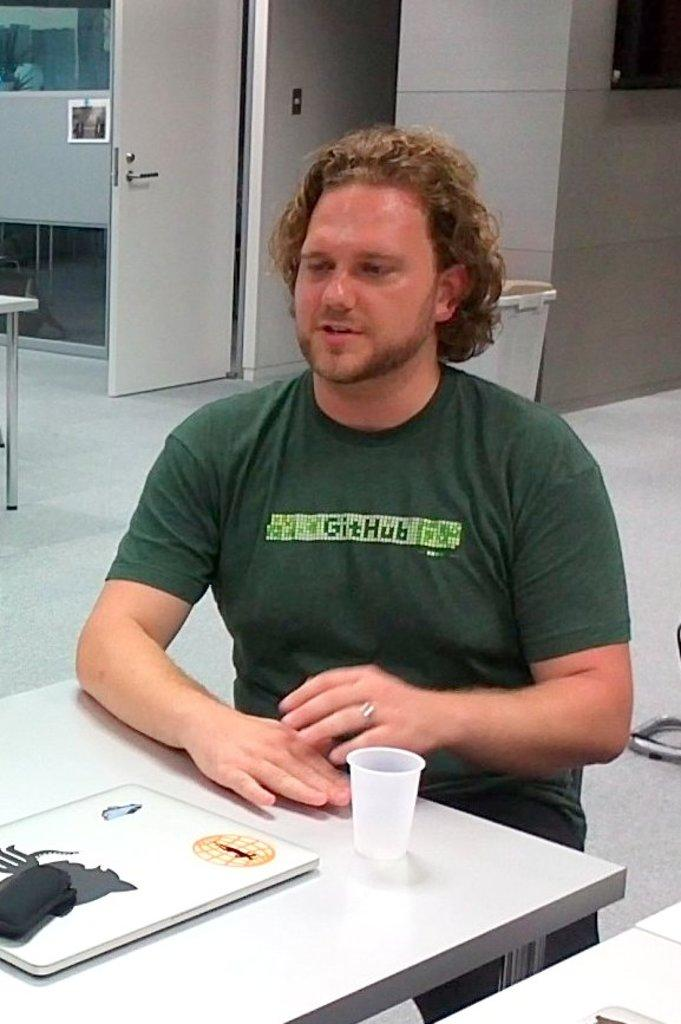Who is present in the image? There is a man in the image. What is the man doing in the image? The man is sitting on a chair. What objects can be seen on the table in the image? There is a glass and a laptop on the table. What type of judgment is the owl making in the image? There is no owl present in the image, so it is not possible to determine any judgments being made. 